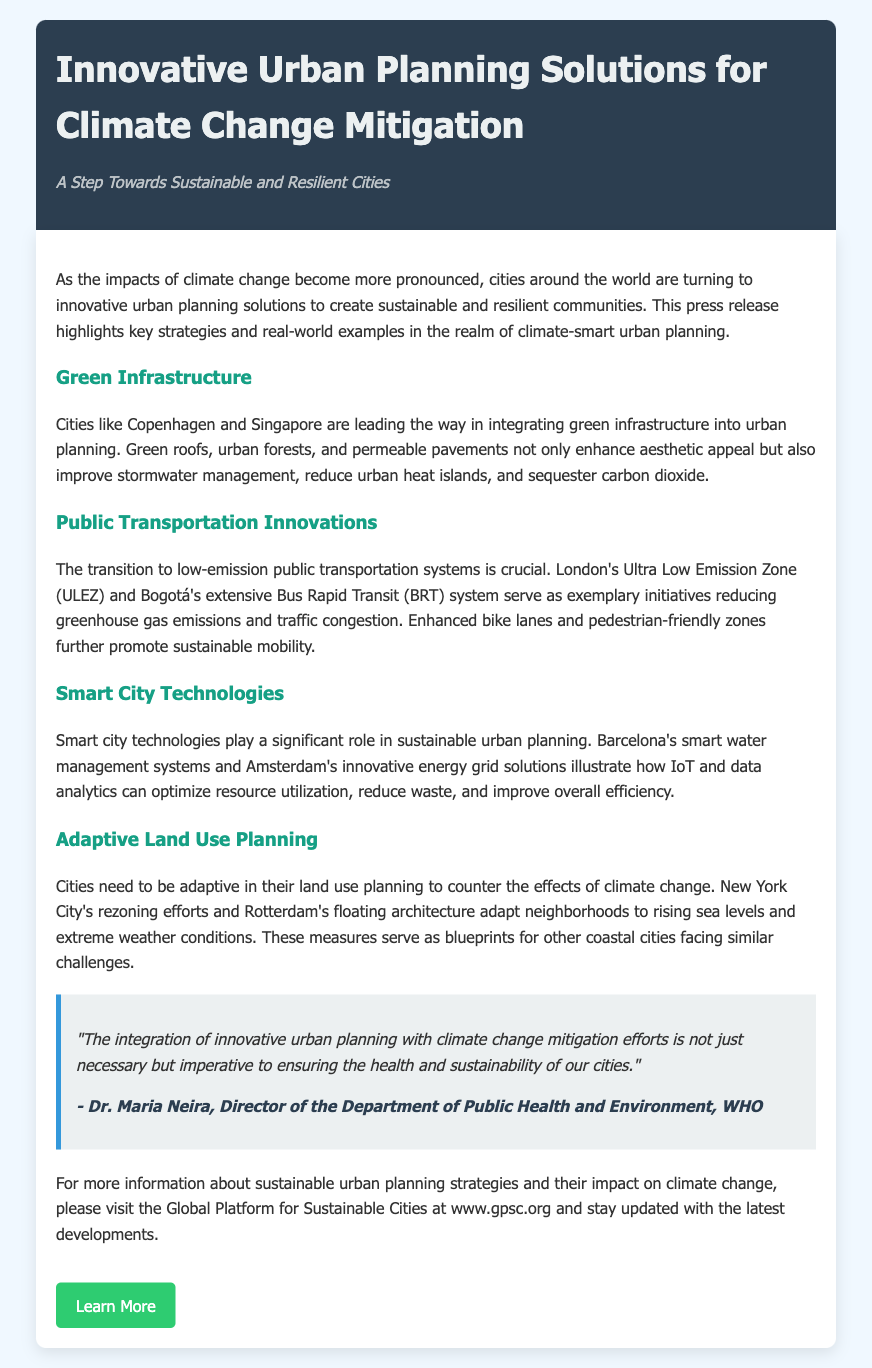What is the title of the press release? The title clearly states the focus of the document as "Innovative Urban Planning Solutions for Climate Change Mitigation."
Answer: Innovative Urban Planning Solutions for Climate Change Mitigation Who is the author of the quoted statement in the document? The quote is attributed to Dr. Maria Neira, identified as the Director of the Department of Public Health and Environment, WHO.
Answer: Dr. Maria Neira What innovative transportation system is mentioned in Bogotá? The document specifically refers to Bogotá's extensive Bus Rapid Transit (BRT) system as an example of public transportation innovation.
Answer: Bus Rapid Transit (BRT) Which city is highlighted for its integration of green infrastructure? Copenhagen is identified as a leading city in the integration of green infrastructure into urban planning.
Answer: Copenhagen What is one feature of smart city technologies mentioned in the document? The document mentions Barcelona's smart water management systems as a significant feature of smart city technologies.
Answer: smart water management systems How do New York City's zoning efforts relate to climate change? The zoning efforts are adaptive measures to counter the effects of climate change, specifically rising sea levels and extreme weather conditions.
Answer: adaptive measures What is the main purpose of the press release? The main purpose is to highlight key strategies and examples in climate-smart urban planning for sustainable and resilient communities.
Answer: Highlight strategies and examples What color is used for the header background? The header background is described as having a color of #2c3e50, which is a dark shade.
Answer: #2c3e50 